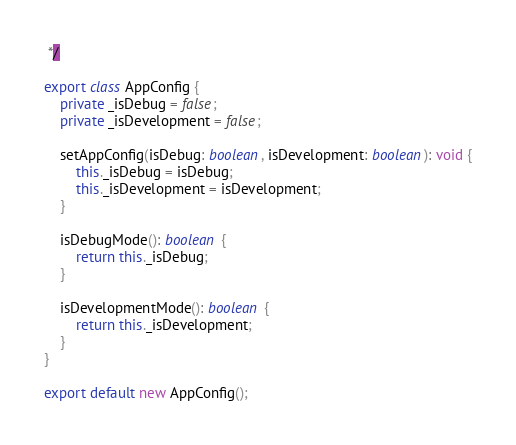Convert code to text. <code><loc_0><loc_0><loc_500><loc_500><_TypeScript_> */

export class AppConfig {
    private _isDebug = false;
    private _isDevelopment = false;

    setAppConfig(isDebug: boolean, isDevelopment: boolean): void {
        this._isDebug = isDebug;
        this._isDevelopment = isDevelopment;
    }

    isDebugMode(): boolean {
        return this._isDebug;
    }

    isDevelopmentMode(): boolean {
        return this._isDevelopment;
    }
}

export default new AppConfig();
</code> 